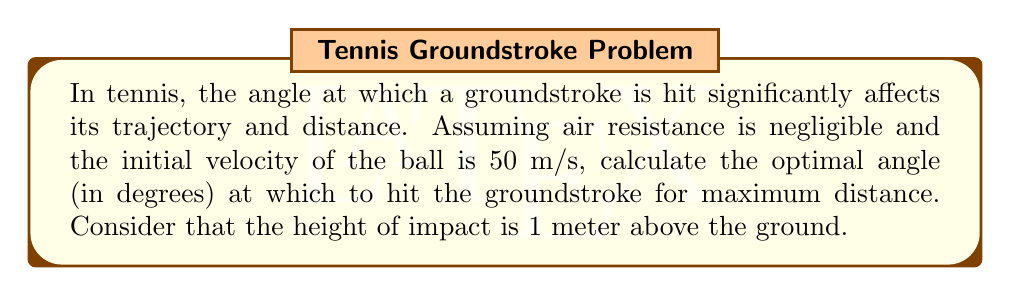What is the answer to this math problem? To solve this problem, we'll use the principles of projectile motion and calculus to maximize the distance traveled by the tennis ball.

1) The range (R) of a projectile launched from height h with initial velocity v at angle θ is given by:

   $$ R = \frac{v \cos θ}{g} \left(v \sin θ + \sqrt{v^2 \sin^2 θ + 2gh}\right) $$

   where g is the acceleration due to gravity (9.8 m/s²).

2) To find the maximum range, we need to differentiate R with respect to θ and set it to zero:

   $$ \frac{dR}{dθ} = 0 $$

3) This leads to the equation:

   $$ \tan θ = \frac{v^2 + \sqrt{v^4 + g^2h^2}}{gh} $$

4) Substituting the given values (v = 50 m/s, h = 1 m, g = 9.8 m/s²):

   $$ \tan θ = \frac{50^2 + \sqrt{50^4 + 9.8^2 \cdot 1^2}}{9.8 \cdot 1} $$

5) Simplifying:

   $$ \tan θ = \frac{2500 + \sqrt{6250000 + 96.04}}{9.8} ≈ 45.53 $$

6) Taking the inverse tangent:

   $$ θ = \tan^{-1}(45.53) ≈ 88.74° $$

This angle is measured from the horizontal. To express it as the angle from the vertical (which is more common in tennis), we subtract it from 90°:

$$ 90° - 88.74° = 1.26° $$

Therefore, the optimal angle for maximum distance, measured from the vertical, is approximately 1.26°.
Answer: The optimal angle for maximum distance in a groundstroke, given the conditions, is approximately 1.26° from the vertical (or 88.74° from the horizontal). 